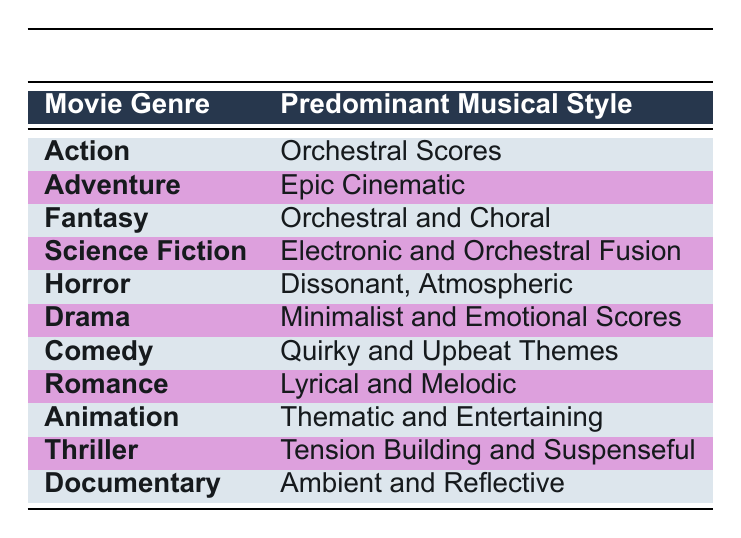What musical style predominates in action films? The table indicates that the predominant musical style for action films is "Orchestral Scores." This information can be directly retrieved from the table under the Action genre.
Answer: Orchestral Scores Which notable composer has worked on both Adventure and Fantasy genres? Looking at the notable composers for both Adventure and Fantasy genres, John Williams appears in both lists, confirming he has worked on scores in both of these genres.
Answer: John Williams True or False: Dissonant, Atmospheric music is the predominant style in Drama films. By checking the table, we see that the predominant musical style listed for Drama is "Minimalist and Emotional Scores," not Dissonant, Atmospheric. Therefore, the statement is false.
Answer: False What are two example films associated with the Romance genre? The table lists "The Way We Were" and "Titanic" as example films under the Romance genre, making it easy to retrieve this information directly from the relevant section.
Answer: The Way We Were, Titanic How many genres have Orchestral as their predominant musical style? Examining the table, we find that Action, Fantasy, and Science Fiction genres feature styles that include "Orchestral Scores" or "Orchestral and Choral." Counting these, there are a total of three genres that feature Orchestral music as their predominant style.
Answer: 3 What is the predominant musical style for the Thriller genre, and which composer is notable for it? The Thriller genre's predominant musical style is "Tension Building and Suspenseful," and notable composers include John Williams, Hans Zimmer, and Lalo Schifrin. This information is accessible by reading the relevant row in the table.
Answer: Tension Building and Suspenseful; John Williams Which two genres have composers who are also known for their contributions to Animation films? The Animation genre features notable composers such as John Williams and Alan Menken. By looking at other genres, we can see that John Williams appears under multiple genres like Action, Drama, and Romance, while Alan Menken is specifically noted in Animation, making both composers associated with this genre.
Answer: Action, Romance, Drama; Animation 